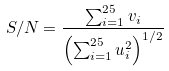<formula> <loc_0><loc_0><loc_500><loc_500>S / N = \frac { \sum _ { i = 1 } ^ { 2 5 } v _ { i } } { \left ( \sum _ { i = 1 } ^ { 2 5 } u _ { i } ^ { 2 } \right ) ^ { 1 / 2 } }</formula> 